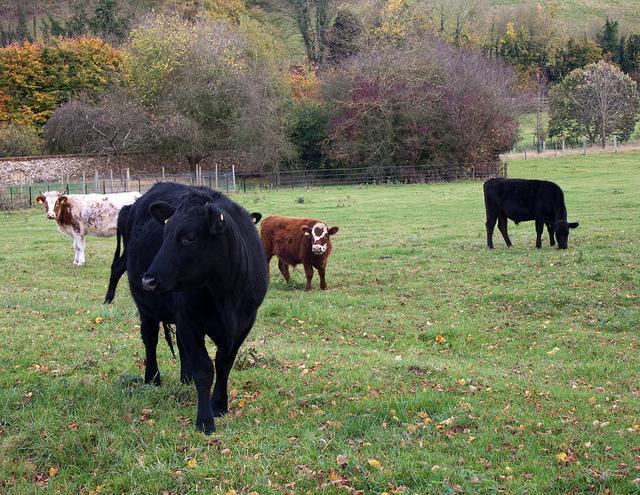How many animals are there?
Give a very brief answer. 4. How many people are there?
Give a very brief answer. 0. How many cattle are on the field?
Give a very brief answer. 4. How many cows are visible?
Give a very brief answer. 4. 